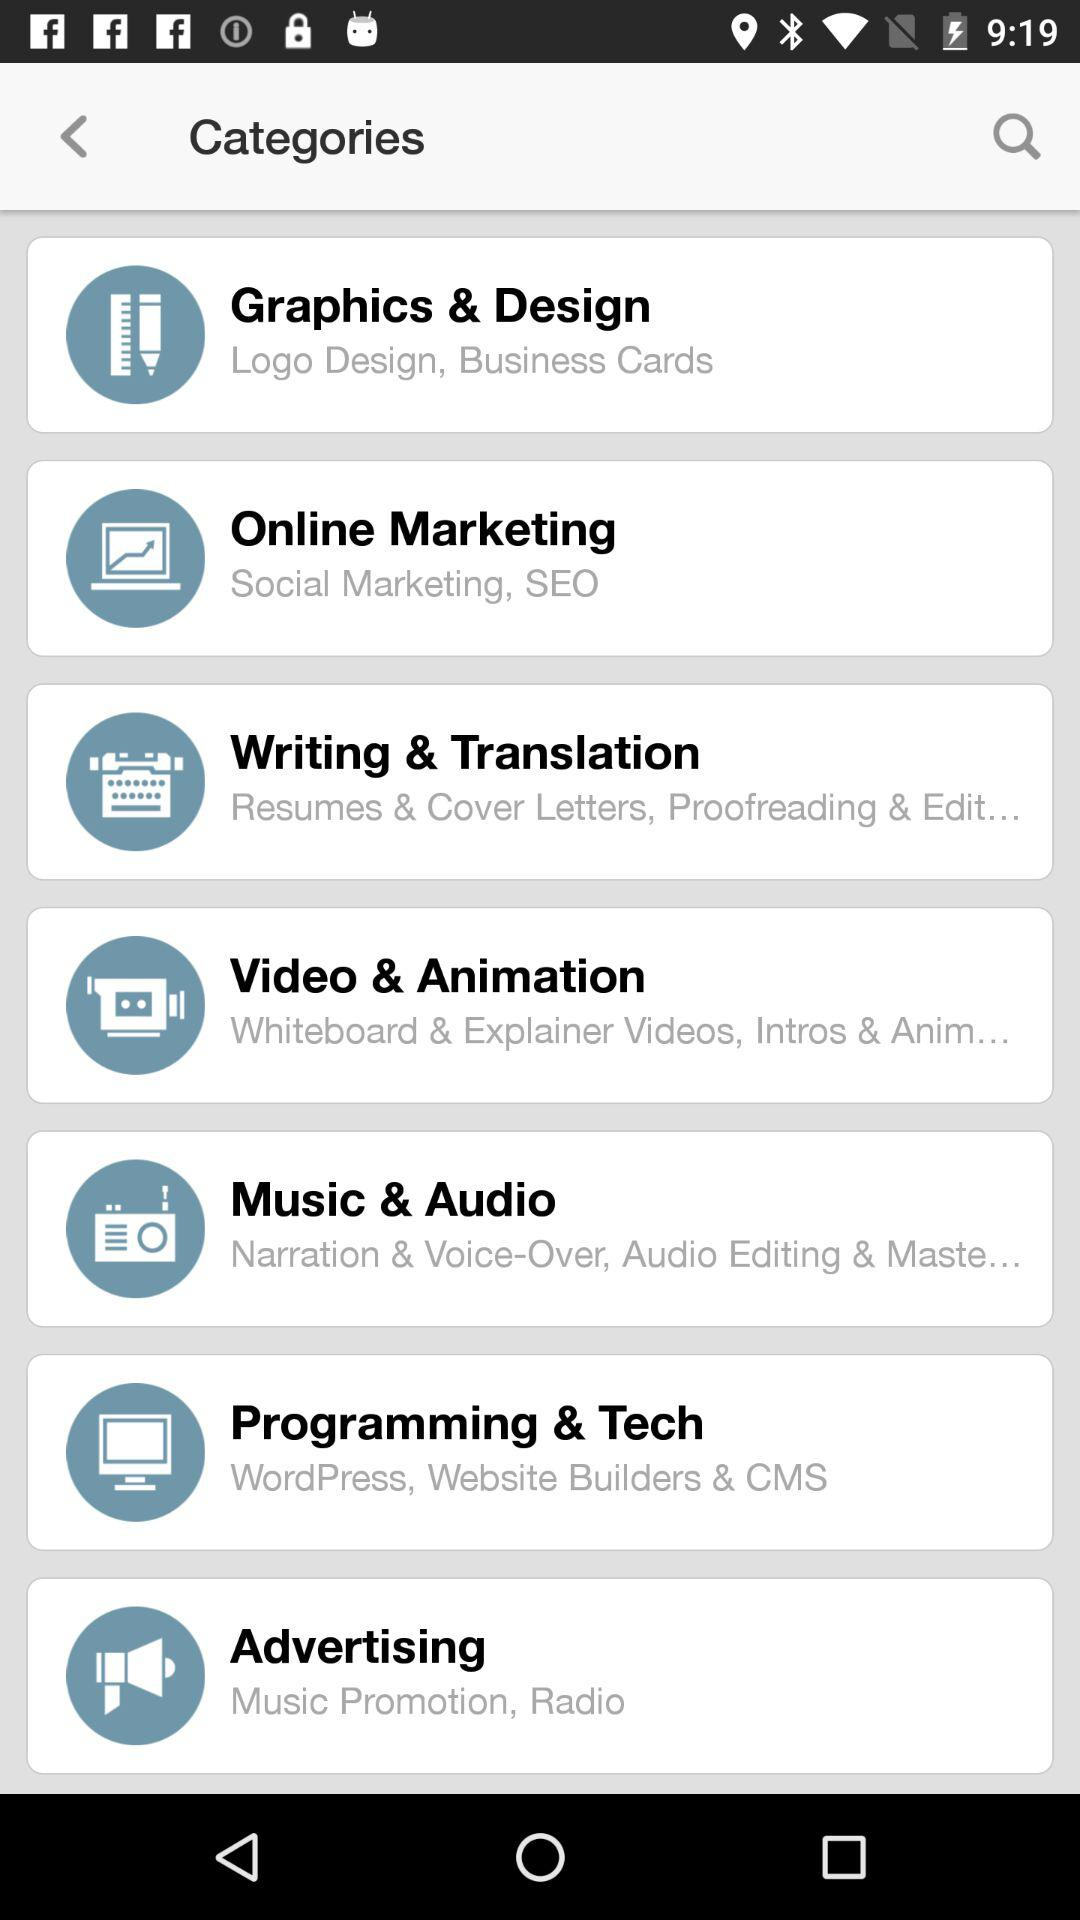What does advertising consist of? The advertising consists of music promotion and radio. 